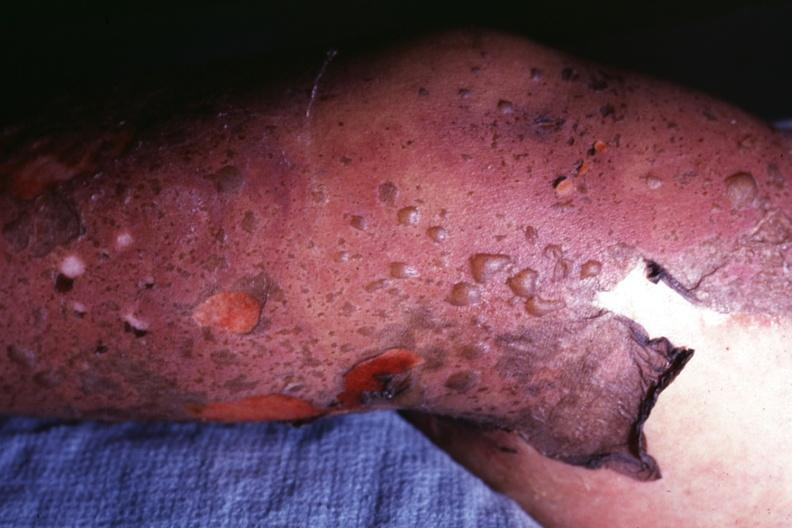s toxic epidermal necrolysis present?
Answer the question using a single word or phrase. Yes 